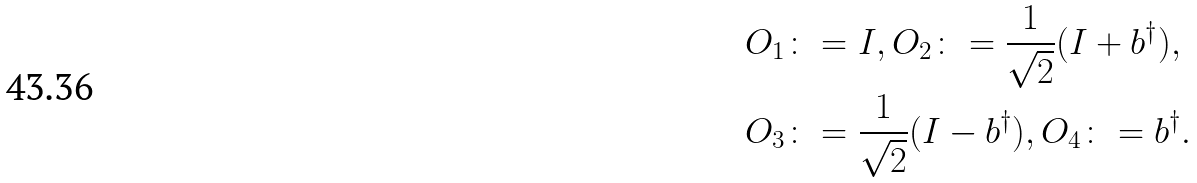Convert formula to latex. <formula><loc_0><loc_0><loc_500><loc_500>& O _ { 1 } \colon = I , O _ { 2 } \colon = \frac { 1 } { \sqrt { 2 } } ( I + b ^ { \dag } ) , \\ & O _ { 3 } \colon = \frac { 1 } { \sqrt { 2 } } ( I - b ^ { \dag } ) , O _ { 4 } \colon = b ^ { \dag } .</formula> 